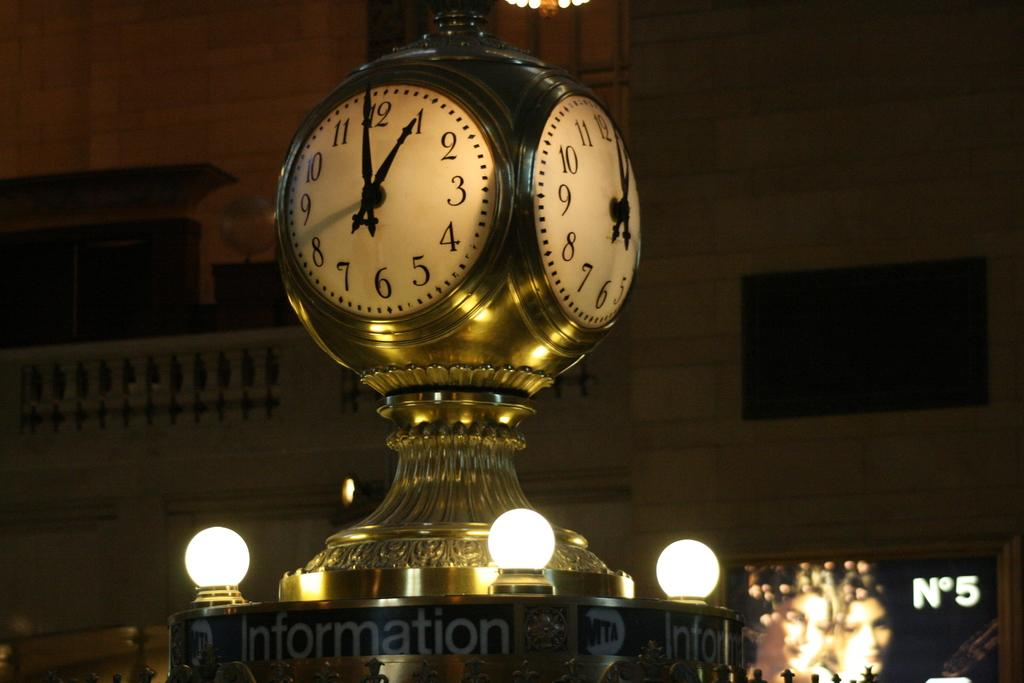<image>
Present a compact description of the photo's key features. Clock that has the word Information right below it. 